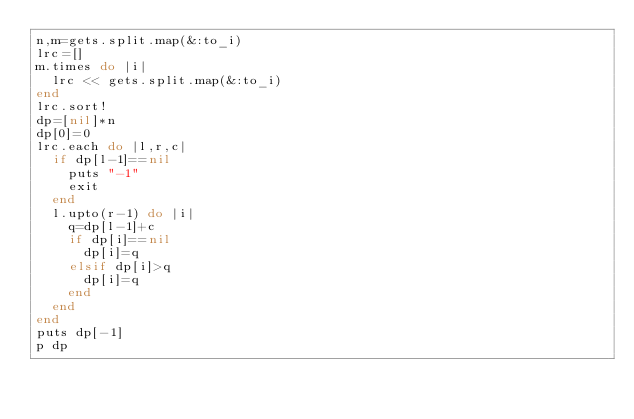Convert code to text. <code><loc_0><loc_0><loc_500><loc_500><_Ruby_>n,m=gets.split.map(&:to_i)
lrc=[]
m.times do |i|
  lrc << gets.split.map(&:to_i)
end
lrc.sort!
dp=[nil]*n
dp[0]=0
lrc.each do |l,r,c|
  if dp[l-1]==nil
    puts "-1"
    exit
  end
  l.upto(r-1) do |i|
    q=dp[l-1]+c
    if dp[i]==nil
      dp[i]=q
    elsif dp[i]>q
      dp[i]=q
    end
  end
end
puts dp[-1]
p dp</code> 